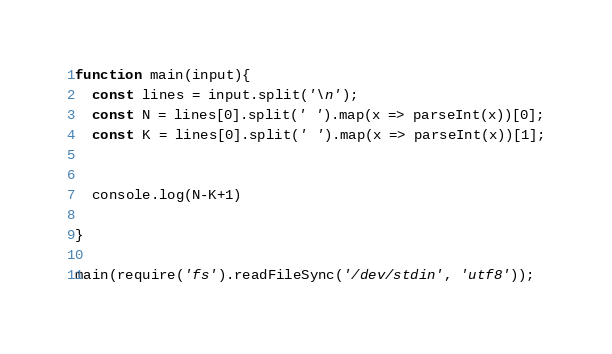<code> <loc_0><loc_0><loc_500><loc_500><_JavaScript_>function main(input){
  const lines = input.split('\n');
  const N = lines[0].split(' ').map(x => parseInt(x))[0];
  const K = lines[0].split(' ').map(x => parseInt(x))[1];


  console.log(N-K+1)

}

main(require('fs').readFileSync('/dev/stdin', 'utf8'));
</code> 